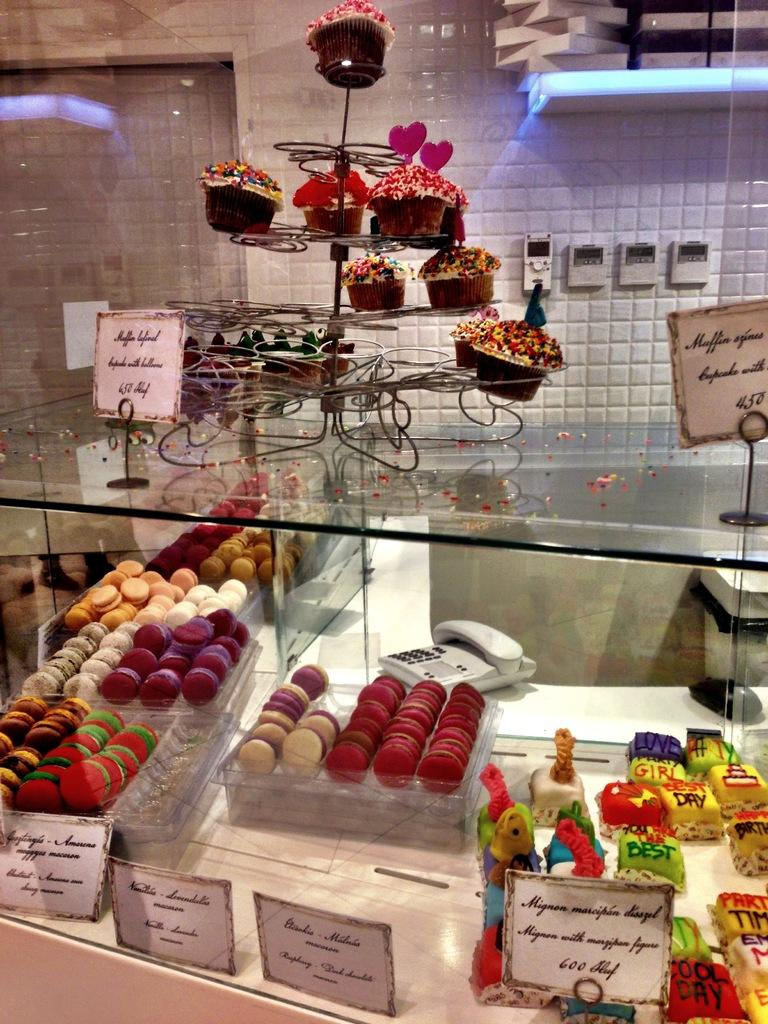What type of dessert is featured in the image? There is a cupcake in the image. What decoration is on the cupcake? The cupcake has sprinkles on it. What object is on the table in the image? There is a name board on the table in the image. What can be identified as a food item in the image? The cupcake is a food item in the image. What communication device is present in the image? There is a telephone in the image. What type of background can be seen in the image? There is a wall visible in the image. How does the harmony of the knee contribute to the overall aesthetic of the image? There is no mention of harmony or a knee in the image, so this question cannot be answered. 